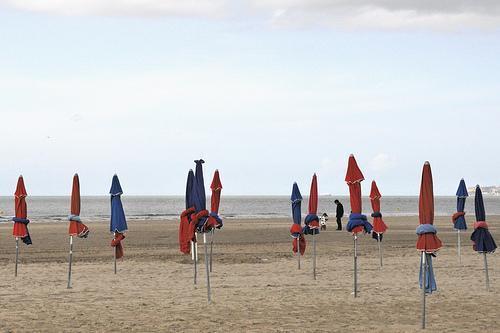How many people are in this picture?
Give a very brief answer. 2. 